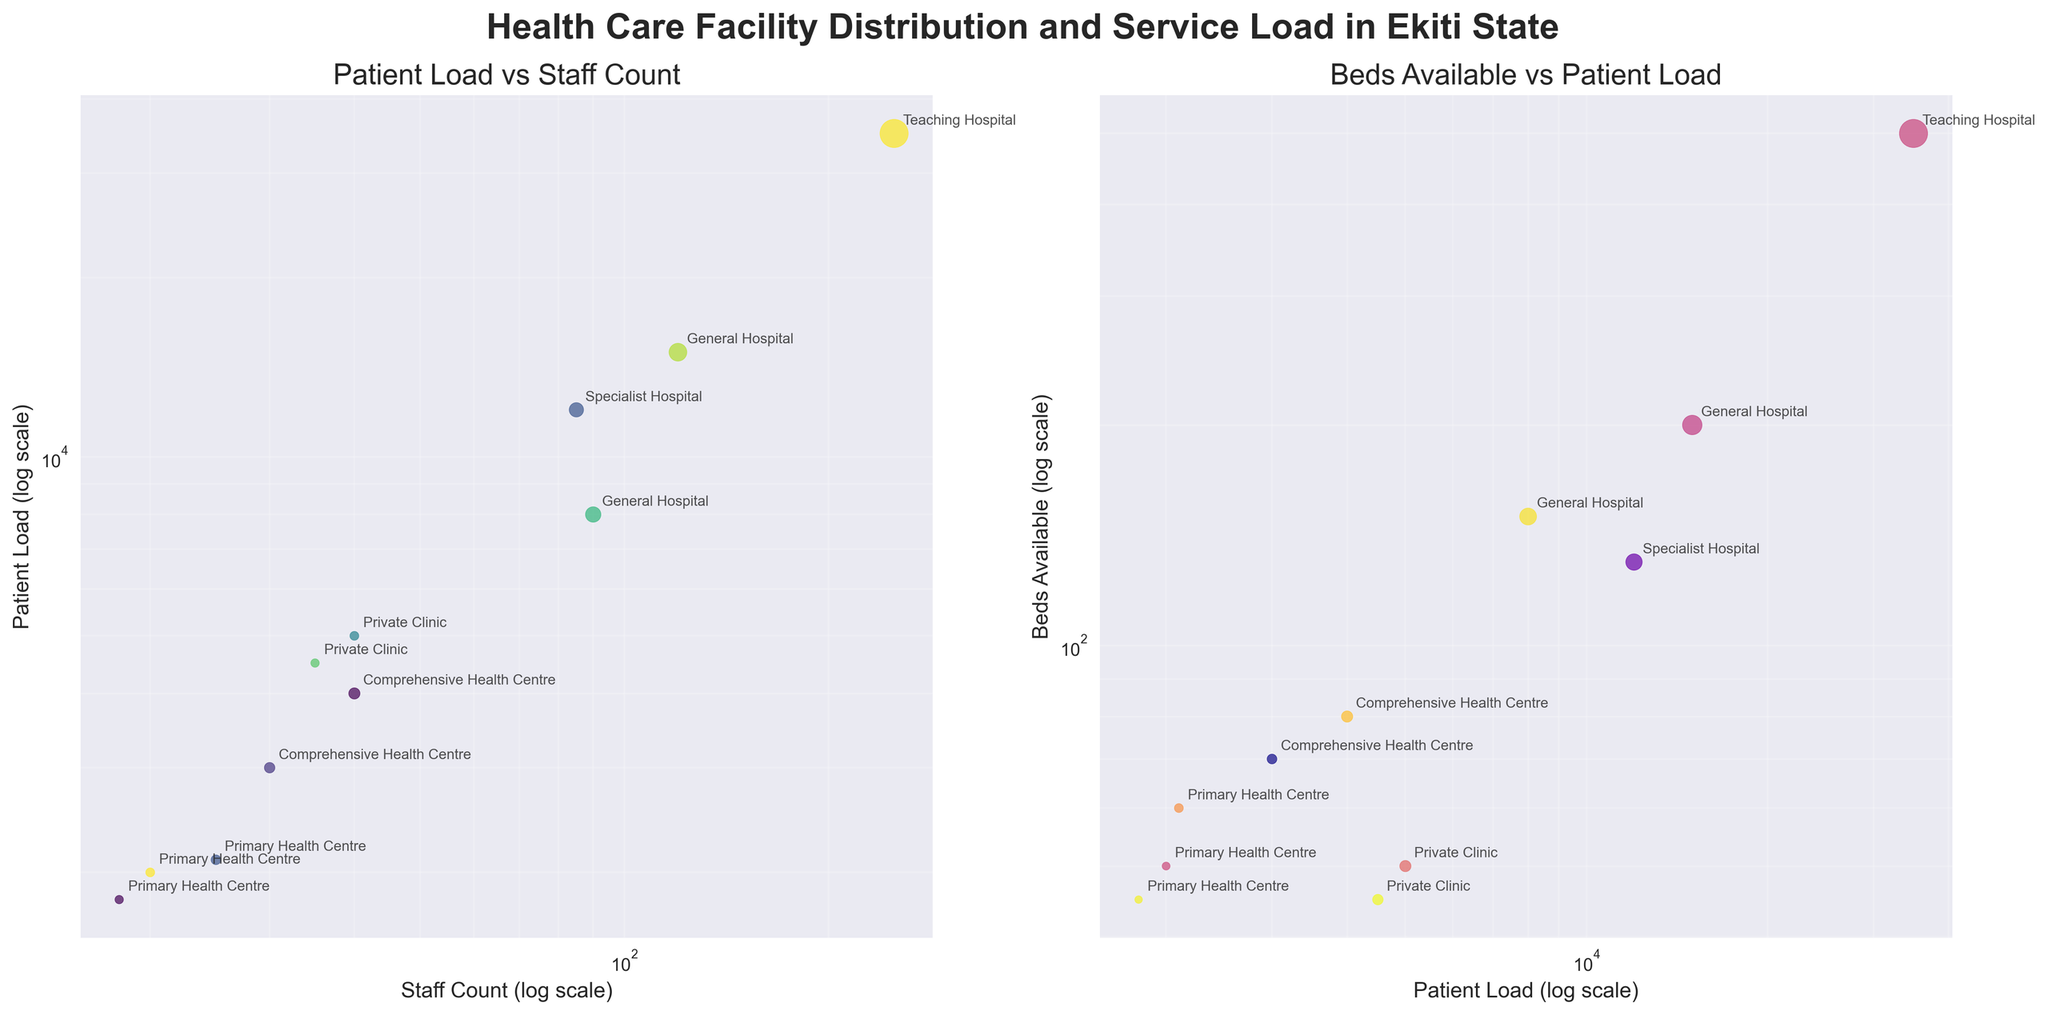What is the title of the entire figure? The title is prominently displayed at the top of the figure. It reads "Health Care Facility Distribution and Service Load in Ekiti State".
Answer: Health Care Facility Distribution and Service Load in Ekiti State What are the two subplots about? The titles of the subplots indicate their contents. The first subplot is "Patient Load vs Staff Count" and the second one is "Beds Available vs Patient Load".
Answer: Patient Load vs Staff Count; Beds Available vs Patient Load Which Healthcare facility has the highest patient load? The highest patient load is in the Teaching Hospital, Ekiti State University. This is observed in the subplot by identifying the data point farthest along on the Patient Load axis.
Answer: Teaching Hospital, Ekiti State University How does the 'General Hospital' at Ado-Ekiti compare to 'General Hospital' at Ikere-Ekiti in terms of staff count and patient load? By looking at the first subplot (Patient Load vs Staff Count), we can compare the points for both hospitals. Ado-Ekiti has about 15000 patients and 120 staff, while Ikere-Ekiti has about 8000 patients and 90 staff.
Answer: Ado-Ekiti: 15000 patients, 120 staff; Ikere-Ekiti: 8000 patients, 90 staff Which healthcare facility has the fewest beds available and what is its patient load? By observing the second subplot (Beds Available vs Patient Load), the Primary Health Centre in Oye has the fewest beds available at 45 and a patient load of 1800.
Answer: Primary Health Centre, Oye; 1800 patients Which facility type has the largest bubble size in the 'Patient Load vs Staff Count' plot and why? The bubble size in the 'Patient Load vs Staff Count' plot corresponds to the number of beds available. The Teaching Hospital, Ekiti State University has the largest bubble, indicating the highest number of beds at 500.
Answer: Teaching Hospital, Ekiti State University Are there any facilities which have similar patient loads but different numbers of beds available? By comparing the points on the second subplot (Beds Available vs Patient Load), General Hospital at Ikere-Ekiti and Specialist Hospital at Ijero-Ekiti have close patient loads but they have different numbers of beds available (150 vs 130).
Answer: General Hospital, Ikere-Ekiti; Specialist Hospital, Ijero-Ekiti Which facility type handles the most patients per staff member? To identify this, we need to compare the ratio of patient load to the number of staff. Teaching Hospital, Ekiti State University with 35000 patients and 250 staff results in 140 patients per staff member, a significantly high ratio.
Answer: Teaching Hospital, Ekiti State University 